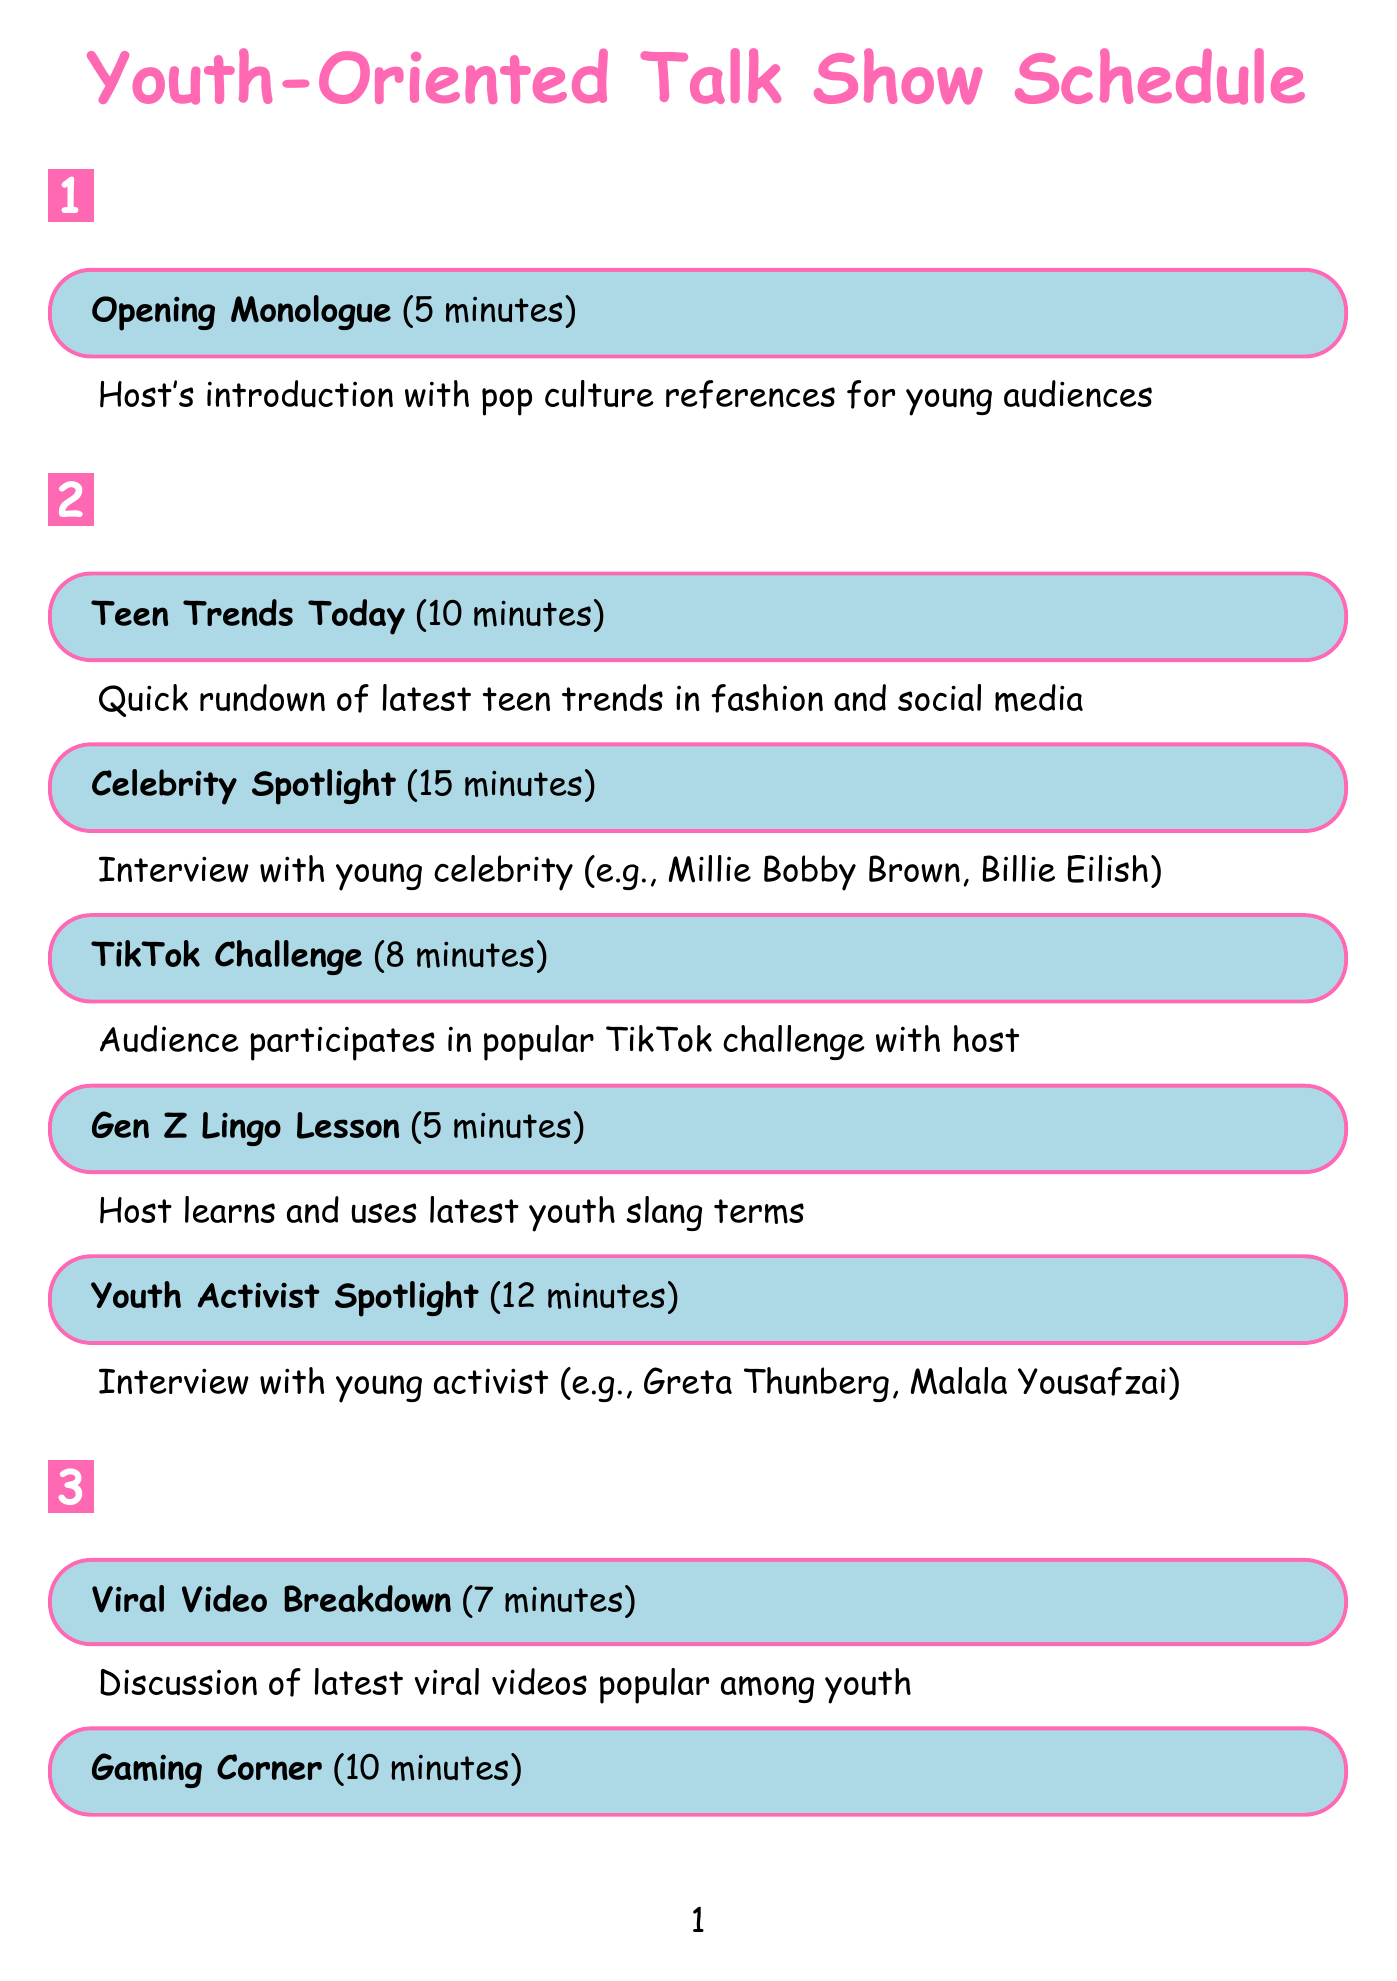What is the duration of the "Celebrity Spotlight"? The duration is specifically stated in the document, highlighting that this segment lasts for 15 minutes.
Answer: 15 minutes Who is a potential guest for the "Youth Activist Spotlight"? The document lists possible guests for this segment, including notable figures like Greta Thunberg and Malala Yousafzai.
Answer: Greta Thunberg What segment comes after "Gen Z Lingo Lesson"? By examining the order of the main segments in the document, the segment that follows is "Youth Activist Spotlight".
Answer: Youth Activist Spotlight How long is the "Gaming Corner"? The duration for this segment is clearly defined in the document as lasting 10 minutes.
Answer: 10 minutes What is the total duration of the main segments listed? The total duration can be calculated by adding the individual times of all main segments, resulting in a total of 77 minutes.
Answer: 77 minutes Who performs in the "Music Minute"? The document provides examples of potential performing artists, such as Olivia Rodrigo and The Kid LAROI.
Answer: Olivia Rodrigo What type of engagement does 'Social Media Integration' involve? The document specifies that this engagement occurs through various platforms such as Instagram, TikTok, and Snapchat.
Answer: Real-time engagement What activity is featured in the "TikTok Challenge"? The document describes this segment as involving audience participation in a popular TikTok challenge.
Answer: Audience participation What is the focus of the "Young Entrepreneur Showcase"? The document states this segment features an interview with a teenage entrepreneur about their business venture.
Answer: Business venture 